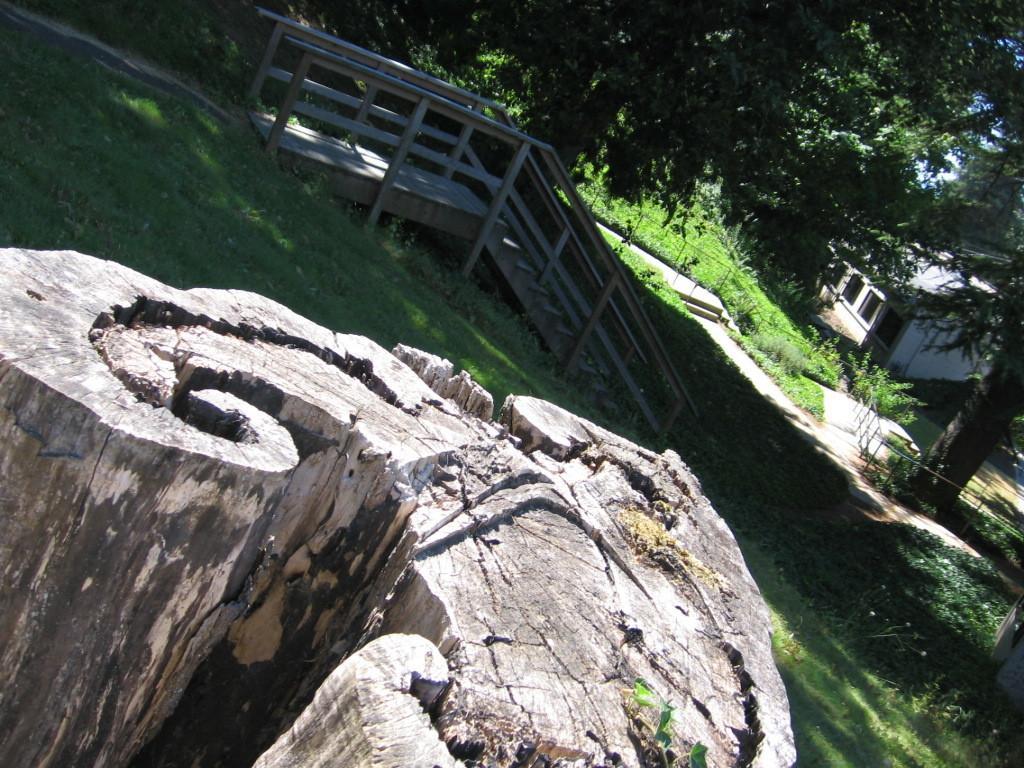How would you summarize this image in a sentence or two? In the foreground I can see a tree trunk, grass and a staircase. In the background I can see plants, trees, fence and a house. This image is taken may be during a sunny day. 